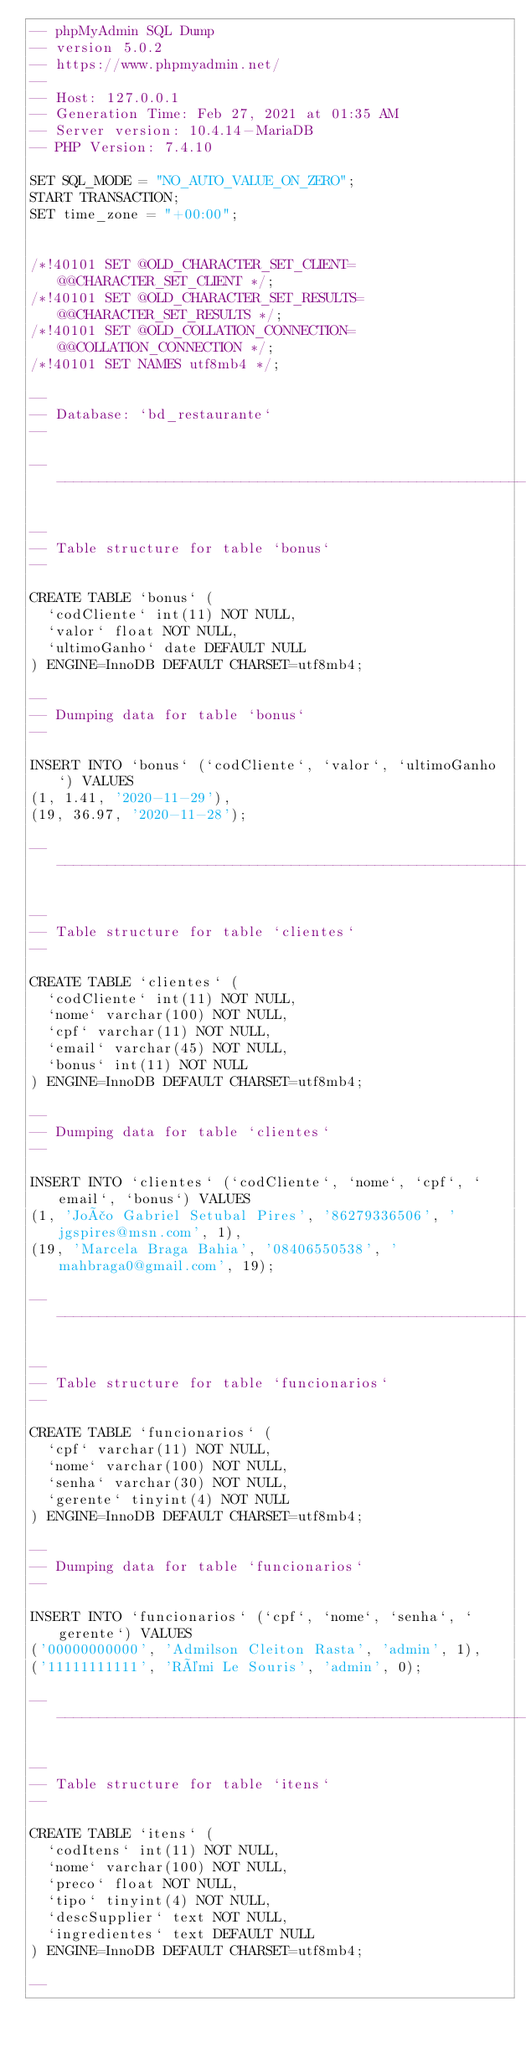<code> <loc_0><loc_0><loc_500><loc_500><_SQL_>-- phpMyAdmin SQL Dump
-- version 5.0.2
-- https://www.phpmyadmin.net/
--
-- Host: 127.0.0.1
-- Generation Time: Feb 27, 2021 at 01:35 AM
-- Server version: 10.4.14-MariaDB
-- PHP Version: 7.4.10

SET SQL_MODE = "NO_AUTO_VALUE_ON_ZERO";
START TRANSACTION;
SET time_zone = "+00:00";


/*!40101 SET @OLD_CHARACTER_SET_CLIENT=@@CHARACTER_SET_CLIENT */;
/*!40101 SET @OLD_CHARACTER_SET_RESULTS=@@CHARACTER_SET_RESULTS */;
/*!40101 SET @OLD_COLLATION_CONNECTION=@@COLLATION_CONNECTION */;
/*!40101 SET NAMES utf8mb4 */;

--
-- Database: `bd_restaurante`
--

-- --------------------------------------------------------

--
-- Table structure for table `bonus`
--

CREATE TABLE `bonus` (
  `codCliente` int(11) NOT NULL,
  `valor` float NOT NULL,
  `ultimoGanho` date DEFAULT NULL
) ENGINE=InnoDB DEFAULT CHARSET=utf8mb4;

--
-- Dumping data for table `bonus`
--

INSERT INTO `bonus` (`codCliente`, `valor`, `ultimoGanho`) VALUES
(1, 1.41, '2020-11-29'),
(19, 36.97, '2020-11-28');

-- --------------------------------------------------------

--
-- Table structure for table `clientes`
--

CREATE TABLE `clientes` (
  `codCliente` int(11) NOT NULL,
  `nome` varchar(100) NOT NULL,
  `cpf` varchar(11) NOT NULL,
  `email` varchar(45) NOT NULL,
  `bonus` int(11) NOT NULL
) ENGINE=InnoDB DEFAULT CHARSET=utf8mb4;

--
-- Dumping data for table `clientes`
--

INSERT INTO `clientes` (`codCliente`, `nome`, `cpf`, `email`, `bonus`) VALUES
(1, 'João Gabriel Setubal Pires', '86279336506', 'jgspires@msn.com', 1),
(19, 'Marcela Braga Bahia', '08406550538', 'mahbraga0@gmail.com', 19);

-- --------------------------------------------------------

--
-- Table structure for table `funcionarios`
--

CREATE TABLE `funcionarios` (
  `cpf` varchar(11) NOT NULL,
  `nome` varchar(100) NOT NULL,
  `senha` varchar(30) NOT NULL,
  `gerente` tinyint(4) NOT NULL
) ENGINE=InnoDB DEFAULT CHARSET=utf8mb4;

--
-- Dumping data for table `funcionarios`
--

INSERT INTO `funcionarios` (`cpf`, `nome`, `senha`, `gerente`) VALUES
('00000000000', 'Admilson Cleiton Rasta', 'admin', 1),
('11111111111', 'Rémi Le Souris', 'admin', 0);

-- --------------------------------------------------------

--
-- Table structure for table `itens`
--

CREATE TABLE `itens` (
  `codItens` int(11) NOT NULL,
  `nome` varchar(100) NOT NULL,
  `preco` float NOT NULL,
  `tipo` tinyint(4) NOT NULL,
  `descSupplier` text NOT NULL,
  `ingredientes` text DEFAULT NULL
) ENGINE=InnoDB DEFAULT CHARSET=utf8mb4;

--</code> 